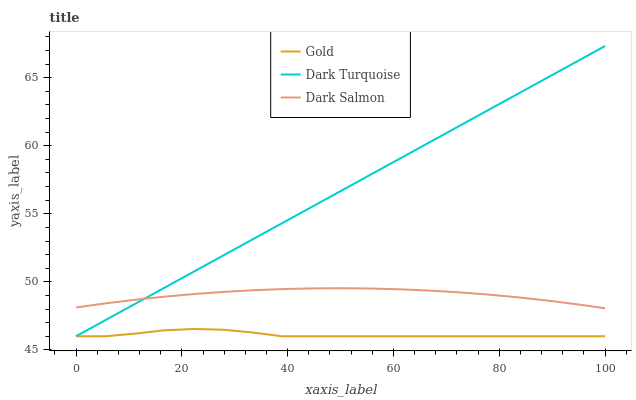Does Gold have the minimum area under the curve?
Answer yes or no. Yes. Does Dark Turquoise have the maximum area under the curve?
Answer yes or no. Yes. Does Dark Salmon have the minimum area under the curve?
Answer yes or no. No. Does Dark Salmon have the maximum area under the curve?
Answer yes or no. No. Is Dark Turquoise the smoothest?
Answer yes or no. Yes. Is Gold the roughest?
Answer yes or no. Yes. Is Dark Salmon the smoothest?
Answer yes or no. No. Is Dark Salmon the roughest?
Answer yes or no. No. Does Dark Turquoise have the lowest value?
Answer yes or no. Yes. Does Dark Salmon have the lowest value?
Answer yes or no. No. Does Dark Turquoise have the highest value?
Answer yes or no. Yes. Does Dark Salmon have the highest value?
Answer yes or no. No. Is Gold less than Dark Salmon?
Answer yes or no. Yes. Is Dark Salmon greater than Gold?
Answer yes or no. Yes. Does Dark Salmon intersect Dark Turquoise?
Answer yes or no. Yes. Is Dark Salmon less than Dark Turquoise?
Answer yes or no. No. Is Dark Salmon greater than Dark Turquoise?
Answer yes or no. No. Does Gold intersect Dark Salmon?
Answer yes or no. No. 